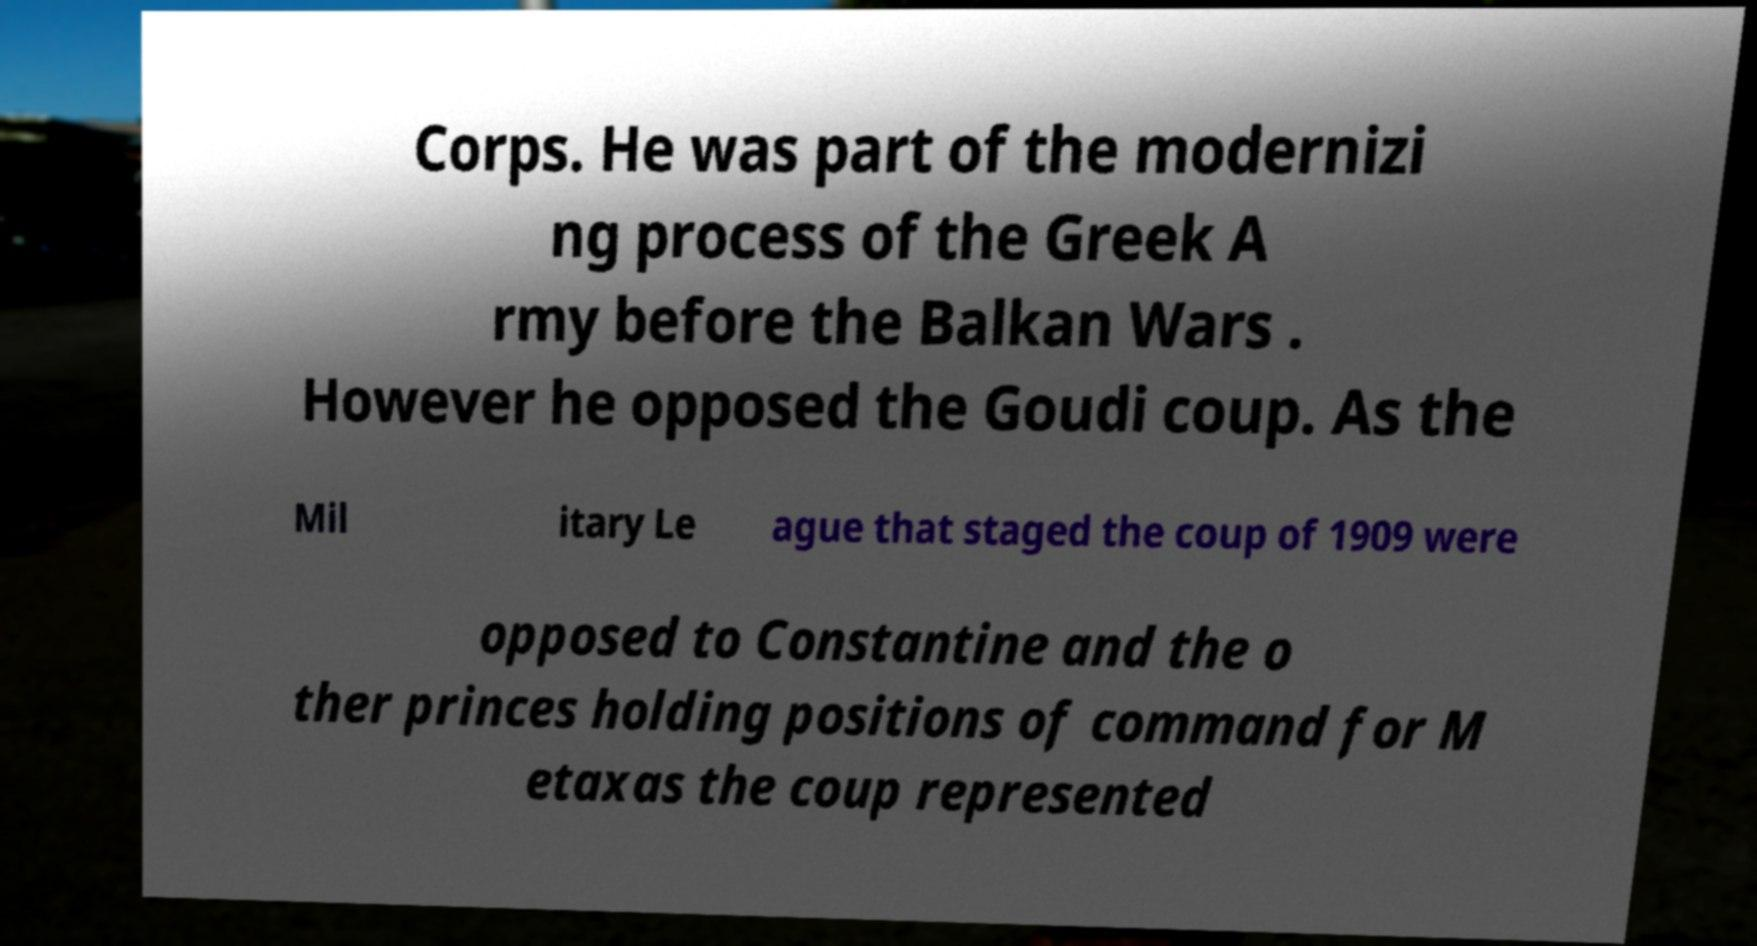I need the written content from this picture converted into text. Can you do that? Corps. He was part of the modernizi ng process of the Greek A rmy before the Balkan Wars . However he opposed the Goudi coup. As the Mil itary Le ague that staged the coup of 1909 were opposed to Constantine and the o ther princes holding positions of command for M etaxas the coup represented 